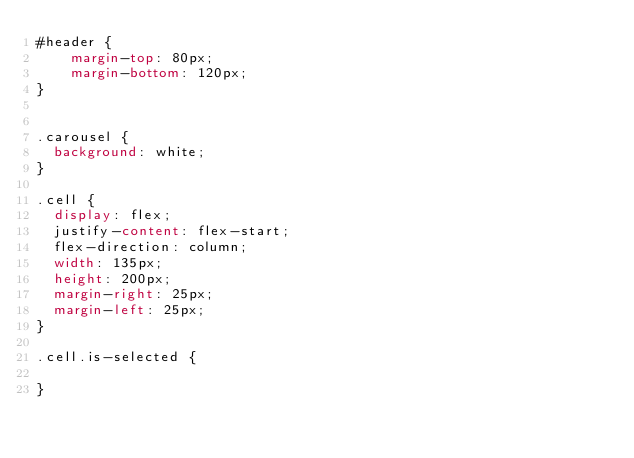Convert code to text. <code><loc_0><loc_0><loc_500><loc_500><_CSS_>#header {
    margin-top: 80px;
    margin-bottom: 120px;
}


.carousel {
  background: white;
}

.cell {
  display: flex;
  justify-content: flex-start;
  flex-direction: column;
  width: 135px;
  height: 200px;
  margin-right: 25px;
  margin-left: 25px;
}

.cell.is-selected {
  
}

</code> 